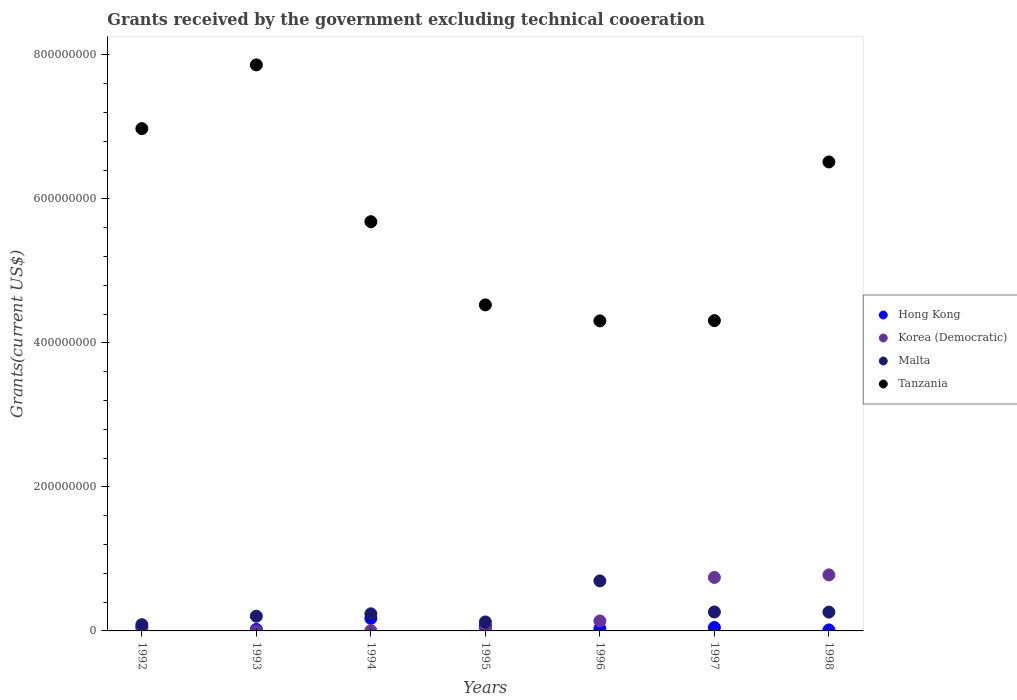Is the number of dotlines equal to the number of legend labels?
Give a very brief answer. Yes. What is the total grants received by the government in Malta in 1998?
Provide a succinct answer. 2.62e+07. Across all years, what is the maximum total grants received by the government in Malta?
Your response must be concise. 6.95e+07. Across all years, what is the minimum total grants received by the government in Malta?
Your answer should be very brief. 8.70e+06. What is the total total grants received by the government in Korea (Democratic) in the graph?
Give a very brief answer. 1.69e+08. What is the difference between the total grants received by the government in Tanzania in 1993 and that in 1995?
Keep it short and to the point. 3.33e+08. What is the difference between the total grants received by the government in Malta in 1998 and the total grants received by the government in Korea (Democratic) in 1994?
Provide a short and direct response. 2.58e+07. What is the average total grants received by the government in Malta per year?
Ensure brevity in your answer.  2.68e+07. In the year 1994, what is the difference between the total grants received by the government in Korea (Democratic) and total grants received by the government in Tanzania?
Provide a succinct answer. -5.68e+08. What is the ratio of the total grants received by the government in Korea (Democratic) in 1992 to that in 1998?
Your answer should be very brief. 0. Is the total grants received by the government in Tanzania in 1992 less than that in 1993?
Your answer should be very brief. Yes. Is the difference between the total grants received by the government in Korea (Democratic) in 1993 and 1997 greater than the difference between the total grants received by the government in Tanzania in 1993 and 1997?
Offer a very short reply. No. What is the difference between the highest and the second highest total grants received by the government in Hong Kong?
Offer a very short reply. 1.10e+07. What is the difference between the highest and the lowest total grants received by the government in Hong Kong?
Keep it short and to the point. 1.60e+07. In how many years, is the total grants received by the government in Malta greater than the average total grants received by the government in Malta taken over all years?
Provide a succinct answer. 1. Is the sum of the total grants received by the government in Hong Kong in 1993 and 1994 greater than the maximum total grants received by the government in Tanzania across all years?
Provide a short and direct response. No. Is it the case that in every year, the sum of the total grants received by the government in Tanzania and total grants received by the government in Hong Kong  is greater than the sum of total grants received by the government in Korea (Democratic) and total grants received by the government in Malta?
Ensure brevity in your answer.  No. Is it the case that in every year, the sum of the total grants received by the government in Malta and total grants received by the government in Tanzania  is greater than the total grants received by the government in Korea (Democratic)?
Your answer should be very brief. Yes. Is the total grants received by the government in Hong Kong strictly greater than the total grants received by the government in Tanzania over the years?
Ensure brevity in your answer.  No. Is the total grants received by the government in Korea (Democratic) strictly less than the total grants received by the government in Hong Kong over the years?
Your answer should be compact. No. How many years are there in the graph?
Your response must be concise. 7. What is the difference between two consecutive major ticks on the Y-axis?
Your answer should be very brief. 2.00e+08. Does the graph contain any zero values?
Keep it short and to the point. No. Does the graph contain grids?
Make the answer very short. No. How many legend labels are there?
Keep it short and to the point. 4. How are the legend labels stacked?
Provide a short and direct response. Vertical. What is the title of the graph?
Your answer should be very brief. Grants received by the government excluding technical cooeration. Does "Small states" appear as one of the legend labels in the graph?
Make the answer very short. No. What is the label or title of the Y-axis?
Your answer should be very brief. Grants(current US$). What is the Grants(current US$) in Hong Kong in 1992?
Your response must be concise. 5.16e+06. What is the Grants(current US$) of Korea (Democratic) in 1992?
Provide a succinct answer. 2.00e+04. What is the Grants(current US$) in Malta in 1992?
Provide a short and direct response. 8.70e+06. What is the Grants(current US$) of Tanzania in 1992?
Your answer should be compact. 6.98e+08. What is the Grants(current US$) in Hong Kong in 1993?
Offer a terse response. 2.14e+06. What is the Grants(current US$) in Korea (Democratic) in 1993?
Offer a very short reply. 4.00e+04. What is the Grants(current US$) of Malta in 1993?
Offer a very short reply. 2.04e+07. What is the Grants(current US$) in Tanzania in 1993?
Provide a succinct answer. 7.86e+08. What is the Grants(current US$) of Hong Kong in 1994?
Provide a short and direct response. 1.74e+07. What is the Grants(current US$) of Korea (Democratic) in 1994?
Ensure brevity in your answer.  3.70e+05. What is the Grants(current US$) of Malta in 1994?
Provide a short and direct response. 2.38e+07. What is the Grants(current US$) in Tanzania in 1994?
Offer a very short reply. 5.68e+08. What is the Grants(current US$) of Hong Kong in 1995?
Keep it short and to the point. 6.44e+06. What is the Grants(current US$) of Korea (Democratic) in 1995?
Give a very brief answer. 2.97e+06. What is the Grants(current US$) of Malta in 1995?
Offer a terse response. 1.25e+07. What is the Grants(current US$) in Tanzania in 1995?
Your response must be concise. 4.53e+08. What is the Grants(current US$) of Hong Kong in 1996?
Your response must be concise. 3.27e+06. What is the Grants(current US$) of Korea (Democratic) in 1996?
Your response must be concise. 1.38e+07. What is the Grants(current US$) of Malta in 1996?
Keep it short and to the point. 6.95e+07. What is the Grants(current US$) in Tanzania in 1996?
Provide a short and direct response. 4.31e+08. What is the Grants(current US$) in Hong Kong in 1997?
Provide a succinct answer. 4.82e+06. What is the Grants(current US$) of Korea (Democratic) in 1997?
Your response must be concise. 7.43e+07. What is the Grants(current US$) in Malta in 1997?
Give a very brief answer. 2.63e+07. What is the Grants(current US$) of Tanzania in 1997?
Provide a short and direct response. 4.31e+08. What is the Grants(current US$) of Hong Kong in 1998?
Your answer should be very brief. 1.39e+06. What is the Grants(current US$) of Korea (Democratic) in 1998?
Make the answer very short. 7.79e+07. What is the Grants(current US$) in Malta in 1998?
Your answer should be compact. 2.62e+07. What is the Grants(current US$) of Tanzania in 1998?
Your answer should be very brief. 6.51e+08. Across all years, what is the maximum Grants(current US$) of Hong Kong?
Keep it short and to the point. 1.74e+07. Across all years, what is the maximum Grants(current US$) of Korea (Democratic)?
Make the answer very short. 7.79e+07. Across all years, what is the maximum Grants(current US$) of Malta?
Provide a succinct answer. 6.95e+07. Across all years, what is the maximum Grants(current US$) of Tanzania?
Provide a short and direct response. 7.86e+08. Across all years, what is the minimum Grants(current US$) in Hong Kong?
Ensure brevity in your answer.  1.39e+06. Across all years, what is the minimum Grants(current US$) of Korea (Democratic)?
Your answer should be very brief. 2.00e+04. Across all years, what is the minimum Grants(current US$) of Malta?
Your answer should be compact. 8.70e+06. Across all years, what is the minimum Grants(current US$) in Tanzania?
Your response must be concise. 4.31e+08. What is the total Grants(current US$) of Hong Kong in the graph?
Provide a succinct answer. 4.06e+07. What is the total Grants(current US$) of Korea (Democratic) in the graph?
Provide a succinct answer. 1.69e+08. What is the total Grants(current US$) in Malta in the graph?
Provide a short and direct response. 1.87e+08. What is the total Grants(current US$) of Tanzania in the graph?
Ensure brevity in your answer.  4.02e+09. What is the difference between the Grants(current US$) of Hong Kong in 1992 and that in 1993?
Your answer should be very brief. 3.02e+06. What is the difference between the Grants(current US$) in Korea (Democratic) in 1992 and that in 1993?
Keep it short and to the point. -2.00e+04. What is the difference between the Grants(current US$) in Malta in 1992 and that in 1993?
Make the answer very short. -1.17e+07. What is the difference between the Grants(current US$) in Tanzania in 1992 and that in 1993?
Your answer should be very brief. -8.86e+07. What is the difference between the Grants(current US$) of Hong Kong in 1992 and that in 1994?
Give a very brief answer. -1.23e+07. What is the difference between the Grants(current US$) of Korea (Democratic) in 1992 and that in 1994?
Offer a terse response. -3.50e+05. What is the difference between the Grants(current US$) of Malta in 1992 and that in 1994?
Provide a succinct answer. -1.51e+07. What is the difference between the Grants(current US$) of Tanzania in 1992 and that in 1994?
Keep it short and to the point. 1.29e+08. What is the difference between the Grants(current US$) of Hong Kong in 1992 and that in 1995?
Provide a short and direct response. -1.28e+06. What is the difference between the Grants(current US$) in Korea (Democratic) in 1992 and that in 1995?
Offer a terse response. -2.95e+06. What is the difference between the Grants(current US$) in Malta in 1992 and that in 1995?
Ensure brevity in your answer.  -3.77e+06. What is the difference between the Grants(current US$) in Tanzania in 1992 and that in 1995?
Ensure brevity in your answer.  2.45e+08. What is the difference between the Grants(current US$) of Hong Kong in 1992 and that in 1996?
Make the answer very short. 1.89e+06. What is the difference between the Grants(current US$) of Korea (Democratic) in 1992 and that in 1996?
Your answer should be compact. -1.38e+07. What is the difference between the Grants(current US$) in Malta in 1992 and that in 1996?
Give a very brief answer. -6.08e+07. What is the difference between the Grants(current US$) of Tanzania in 1992 and that in 1996?
Your response must be concise. 2.67e+08. What is the difference between the Grants(current US$) in Hong Kong in 1992 and that in 1997?
Your response must be concise. 3.40e+05. What is the difference between the Grants(current US$) of Korea (Democratic) in 1992 and that in 1997?
Your response must be concise. -7.42e+07. What is the difference between the Grants(current US$) in Malta in 1992 and that in 1997?
Your answer should be very brief. -1.76e+07. What is the difference between the Grants(current US$) of Tanzania in 1992 and that in 1997?
Provide a succinct answer. 2.67e+08. What is the difference between the Grants(current US$) in Hong Kong in 1992 and that in 1998?
Give a very brief answer. 3.77e+06. What is the difference between the Grants(current US$) of Korea (Democratic) in 1992 and that in 1998?
Offer a terse response. -7.78e+07. What is the difference between the Grants(current US$) of Malta in 1992 and that in 1998?
Your answer should be compact. -1.74e+07. What is the difference between the Grants(current US$) in Tanzania in 1992 and that in 1998?
Provide a succinct answer. 4.63e+07. What is the difference between the Grants(current US$) of Hong Kong in 1993 and that in 1994?
Ensure brevity in your answer.  -1.53e+07. What is the difference between the Grants(current US$) in Korea (Democratic) in 1993 and that in 1994?
Make the answer very short. -3.30e+05. What is the difference between the Grants(current US$) in Malta in 1993 and that in 1994?
Give a very brief answer. -3.34e+06. What is the difference between the Grants(current US$) of Tanzania in 1993 and that in 1994?
Offer a terse response. 2.18e+08. What is the difference between the Grants(current US$) of Hong Kong in 1993 and that in 1995?
Provide a succinct answer. -4.30e+06. What is the difference between the Grants(current US$) of Korea (Democratic) in 1993 and that in 1995?
Provide a succinct answer. -2.93e+06. What is the difference between the Grants(current US$) of Malta in 1993 and that in 1995?
Ensure brevity in your answer.  7.97e+06. What is the difference between the Grants(current US$) of Tanzania in 1993 and that in 1995?
Offer a very short reply. 3.33e+08. What is the difference between the Grants(current US$) of Hong Kong in 1993 and that in 1996?
Give a very brief answer. -1.13e+06. What is the difference between the Grants(current US$) of Korea (Democratic) in 1993 and that in 1996?
Offer a terse response. -1.38e+07. What is the difference between the Grants(current US$) in Malta in 1993 and that in 1996?
Ensure brevity in your answer.  -4.90e+07. What is the difference between the Grants(current US$) in Tanzania in 1993 and that in 1996?
Provide a succinct answer. 3.56e+08. What is the difference between the Grants(current US$) in Hong Kong in 1993 and that in 1997?
Keep it short and to the point. -2.68e+06. What is the difference between the Grants(current US$) in Korea (Democratic) in 1993 and that in 1997?
Your answer should be compact. -7.42e+07. What is the difference between the Grants(current US$) of Malta in 1993 and that in 1997?
Ensure brevity in your answer.  -5.89e+06. What is the difference between the Grants(current US$) in Tanzania in 1993 and that in 1997?
Make the answer very short. 3.55e+08. What is the difference between the Grants(current US$) of Hong Kong in 1993 and that in 1998?
Your answer should be very brief. 7.50e+05. What is the difference between the Grants(current US$) in Korea (Democratic) in 1993 and that in 1998?
Give a very brief answer. -7.78e+07. What is the difference between the Grants(current US$) in Malta in 1993 and that in 1998?
Offer a very short reply. -5.71e+06. What is the difference between the Grants(current US$) of Tanzania in 1993 and that in 1998?
Offer a very short reply. 1.35e+08. What is the difference between the Grants(current US$) of Hong Kong in 1994 and that in 1995?
Provide a succinct answer. 1.10e+07. What is the difference between the Grants(current US$) of Korea (Democratic) in 1994 and that in 1995?
Provide a succinct answer. -2.60e+06. What is the difference between the Grants(current US$) in Malta in 1994 and that in 1995?
Ensure brevity in your answer.  1.13e+07. What is the difference between the Grants(current US$) of Tanzania in 1994 and that in 1995?
Offer a very short reply. 1.16e+08. What is the difference between the Grants(current US$) of Hong Kong in 1994 and that in 1996?
Provide a short and direct response. 1.42e+07. What is the difference between the Grants(current US$) of Korea (Democratic) in 1994 and that in 1996?
Ensure brevity in your answer.  -1.34e+07. What is the difference between the Grants(current US$) in Malta in 1994 and that in 1996?
Your answer should be very brief. -4.57e+07. What is the difference between the Grants(current US$) of Tanzania in 1994 and that in 1996?
Your answer should be very brief. 1.38e+08. What is the difference between the Grants(current US$) in Hong Kong in 1994 and that in 1997?
Make the answer very short. 1.26e+07. What is the difference between the Grants(current US$) of Korea (Democratic) in 1994 and that in 1997?
Provide a succinct answer. -7.39e+07. What is the difference between the Grants(current US$) of Malta in 1994 and that in 1997?
Your answer should be very brief. -2.55e+06. What is the difference between the Grants(current US$) of Tanzania in 1994 and that in 1997?
Your response must be concise. 1.37e+08. What is the difference between the Grants(current US$) in Hong Kong in 1994 and that in 1998?
Provide a short and direct response. 1.60e+07. What is the difference between the Grants(current US$) of Korea (Democratic) in 1994 and that in 1998?
Keep it short and to the point. -7.75e+07. What is the difference between the Grants(current US$) of Malta in 1994 and that in 1998?
Ensure brevity in your answer.  -2.37e+06. What is the difference between the Grants(current US$) in Tanzania in 1994 and that in 1998?
Your answer should be compact. -8.30e+07. What is the difference between the Grants(current US$) of Hong Kong in 1995 and that in 1996?
Your response must be concise. 3.17e+06. What is the difference between the Grants(current US$) of Korea (Democratic) in 1995 and that in 1996?
Ensure brevity in your answer.  -1.08e+07. What is the difference between the Grants(current US$) of Malta in 1995 and that in 1996?
Ensure brevity in your answer.  -5.70e+07. What is the difference between the Grants(current US$) in Tanzania in 1995 and that in 1996?
Offer a very short reply. 2.22e+07. What is the difference between the Grants(current US$) of Hong Kong in 1995 and that in 1997?
Offer a very short reply. 1.62e+06. What is the difference between the Grants(current US$) in Korea (Democratic) in 1995 and that in 1997?
Ensure brevity in your answer.  -7.13e+07. What is the difference between the Grants(current US$) in Malta in 1995 and that in 1997?
Your response must be concise. -1.39e+07. What is the difference between the Grants(current US$) of Tanzania in 1995 and that in 1997?
Provide a short and direct response. 2.18e+07. What is the difference between the Grants(current US$) of Hong Kong in 1995 and that in 1998?
Your answer should be very brief. 5.05e+06. What is the difference between the Grants(current US$) of Korea (Democratic) in 1995 and that in 1998?
Offer a very short reply. -7.49e+07. What is the difference between the Grants(current US$) in Malta in 1995 and that in 1998?
Your response must be concise. -1.37e+07. What is the difference between the Grants(current US$) of Tanzania in 1995 and that in 1998?
Your answer should be compact. -1.99e+08. What is the difference between the Grants(current US$) in Hong Kong in 1996 and that in 1997?
Keep it short and to the point. -1.55e+06. What is the difference between the Grants(current US$) of Korea (Democratic) in 1996 and that in 1997?
Provide a short and direct response. -6.05e+07. What is the difference between the Grants(current US$) in Malta in 1996 and that in 1997?
Provide a succinct answer. 4.32e+07. What is the difference between the Grants(current US$) in Tanzania in 1996 and that in 1997?
Give a very brief answer. -3.80e+05. What is the difference between the Grants(current US$) in Hong Kong in 1996 and that in 1998?
Keep it short and to the point. 1.88e+06. What is the difference between the Grants(current US$) of Korea (Democratic) in 1996 and that in 1998?
Offer a very short reply. -6.41e+07. What is the difference between the Grants(current US$) of Malta in 1996 and that in 1998?
Provide a succinct answer. 4.33e+07. What is the difference between the Grants(current US$) in Tanzania in 1996 and that in 1998?
Your response must be concise. -2.21e+08. What is the difference between the Grants(current US$) in Hong Kong in 1997 and that in 1998?
Make the answer very short. 3.43e+06. What is the difference between the Grants(current US$) of Korea (Democratic) in 1997 and that in 1998?
Your answer should be very brief. -3.60e+06. What is the difference between the Grants(current US$) in Tanzania in 1997 and that in 1998?
Your answer should be very brief. -2.20e+08. What is the difference between the Grants(current US$) of Hong Kong in 1992 and the Grants(current US$) of Korea (Democratic) in 1993?
Your response must be concise. 5.12e+06. What is the difference between the Grants(current US$) of Hong Kong in 1992 and the Grants(current US$) of Malta in 1993?
Your response must be concise. -1.53e+07. What is the difference between the Grants(current US$) of Hong Kong in 1992 and the Grants(current US$) of Tanzania in 1993?
Your answer should be compact. -7.81e+08. What is the difference between the Grants(current US$) of Korea (Democratic) in 1992 and the Grants(current US$) of Malta in 1993?
Your answer should be very brief. -2.04e+07. What is the difference between the Grants(current US$) of Korea (Democratic) in 1992 and the Grants(current US$) of Tanzania in 1993?
Give a very brief answer. -7.86e+08. What is the difference between the Grants(current US$) in Malta in 1992 and the Grants(current US$) in Tanzania in 1993?
Keep it short and to the point. -7.78e+08. What is the difference between the Grants(current US$) of Hong Kong in 1992 and the Grants(current US$) of Korea (Democratic) in 1994?
Make the answer very short. 4.79e+06. What is the difference between the Grants(current US$) in Hong Kong in 1992 and the Grants(current US$) in Malta in 1994?
Your response must be concise. -1.86e+07. What is the difference between the Grants(current US$) in Hong Kong in 1992 and the Grants(current US$) in Tanzania in 1994?
Keep it short and to the point. -5.63e+08. What is the difference between the Grants(current US$) of Korea (Democratic) in 1992 and the Grants(current US$) of Malta in 1994?
Keep it short and to the point. -2.38e+07. What is the difference between the Grants(current US$) of Korea (Democratic) in 1992 and the Grants(current US$) of Tanzania in 1994?
Keep it short and to the point. -5.68e+08. What is the difference between the Grants(current US$) in Malta in 1992 and the Grants(current US$) in Tanzania in 1994?
Offer a terse response. -5.60e+08. What is the difference between the Grants(current US$) in Hong Kong in 1992 and the Grants(current US$) in Korea (Democratic) in 1995?
Your answer should be compact. 2.19e+06. What is the difference between the Grants(current US$) in Hong Kong in 1992 and the Grants(current US$) in Malta in 1995?
Your answer should be very brief. -7.31e+06. What is the difference between the Grants(current US$) of Hong Kong in 1992 and the Grants(current US$) of Tanzania in 1995?
Offer a very short reply. -4.48e+08. What is the difference between the Grants(current US$) of Korea (Democratic) in 1992 and the Grants(current US$) of Malta in 1995?
Offer a terse response. -1.24e+07. What is the difference between the Grants(current US$) of Korea (Democratic) in 1992 and the Grants(current US$) of Tanzania in 1995?
Your answer should be compact. -4.53e+08. What is the difference between the Grants(current US$) of Malta in 1992 and the Grants(current US$) of Tanzania in 1995?
Keep it short and to the point. -4.44e+08. What is the difference between the Grants(current US$) of Hong Kong in 1992 and the Grants(current US$) of Korea (Democratic) in 1996?
Your answer should be very brief. -8.65e+06. What is the difference between the Grants(current US$) in Hong Kong in 1992 and the Grants(current US$) in Malta in 1996?
Provide a succinct answer. -6.43e+07. What is the difference between the Grants(current US$) of Hong Kong in 1992 and the Grants(current US$) of Tanzania in 1996?
Offer a very short reply. -4.25e+08. What is the difference between the Grants(current US$) in Korea (Democratic) in 1992 and the Grants(current US$) in Malta in 1996?
Offer a very short reply. -6.95e+07. What is the difference between the Grants(current US$) of Korea (Democratic) in 1992 and the Grants(current US$) of Tanzania in 1996?
Ensure brevity in your answer.  -4.31e+08. What is the difference between the Grants(current US$) in Malta in 1992 and the Grants(current US$) in Tanzania in 1996?
Give a very brief answer. -4.22e+08. What is the difference between the Grants(current US$) of Hong Kong in 1992 and the Grants(current US$) of Korea (Democratic) in 1997?
Ensure brevity in your answer.  -6.91e+07. What is the difference between the Grants(current US$) in Hong Kong in 1992 and the Grants(current US$) in Malta in 1997?
Offer a terse response. -2.12e+07. What is the difference between the Grants(current US$) of Hong Kong in 1992 and the Grants(current US$) of Tanzania in 1997?
Ensure brevity in your answer.  -4.26e+08. What is the difference between the Grants(current US$) of Korea (Democratic) in 1992 and the Grants(current US$) of Malta in 1997?
Make the answer very short. -2.63e+07. What is the difference between the Grants(current US$) in Korea (Democratic) in 1992 and the Grants(current US$) in Tanzania in 1997?
Keep it short and to the point. -4.31e+08. What is the difference between the Grants(current US$) in Malta in 1992 and the Grants(current US$) in Tanzania in 1997?
Your answer should be very brief. -4.22e+08. What is the difference between the Grants(current US$) in Hong Kong in 1992 and the Grants(current US$) in Korea (Democratic) in 1998?
Ensure brevity in your answer.  -7.27e+07. What is the difference between the Grants(current US$) in Hong Kong in 1992 and the Grants(current US$) in Malta in 1998?
Provide a succinct answer. -2.10e+07. What is the difference between the Grants(current US$) of Hong Kong in 1992 and the Grants(current US$) of Tanzania in 1998?
Your answer should be very brief. -6.46e+08. What is the difference between the Grants(current US$) in Korea (Democratic) in 1992 and the Grants(current US$) in Malta in 1998?
Provide a succinct answer. -2.61e+07. What is the difference between the Grants(current US$) of Korea (Democratic) in 1992 and the Grants(current US$) of Tanzania in 1998?
Provide a short and direct response. -6.51e+08. What is the difference between the Grants(current US$) in Malta in 1992 and the Grants(current US$) in Tanzania in 1998?
Your answer should be compact. -6.43e+08. What is the difference between the Grants(current US$) of Hong Kong in 1993 and the Grants(current US$) of Korea (Democratic) in 1994?
Keep it short and to the point. 1.77e+06. What is the difference between the Grants(current US$) in Hong Kong in 1993 and the Grants(current US$) in Malta in 1994?
Make the answer very short. -2.16e+07. What is the difference between the Grants(current US$) of Hong Kong in 1993 and the Grants(current US$) of Tanzania in 1994?
Give a very brief answer. -5.66e+08. What is the difference between the Grants(current US$) in Korea (Democratic) in 1993 and the Grants(current US$) in Malta in 1994?
Keep it short and to the point. -2.37e+07. What is the difference between the Grants(current US$) of Korea (Democratic) in 1993 and the Grants(current US$) of Tanzania in 1994?
Keep it short and to the point. -5.68e+08. What is the difference between the Grants(current US$) of Malta in 1993 and the Grants(current US$) of Tanzania in 1994?
Ensure brevity in your answer.  -5.48e+08. What is the difference between the Grants(current US$) in Hong Kong in 1993 and the Grants(current US$) in Korea (Democratic) in 1995?
Your answer should be compact. -8.30e+05. What is the difference between the Grants(current US$) in Hong Kong in 1993 and the Grants(current US$) in Malta in 1995?
Give a very brief answer. -1.03e+07. What is the difference between the Grants(current US$) of Hong Kong in 1993 and the Grants(current US$) of Tanzania in 1995?
Provide a short and direct response. -4.51e+08. What is the difference between the Grants(current US$) of Korea (Democratic) in 1993 and the Grants(current US$) of Malta in 1995?
Your answer should be compact. -1.24e+07. What is the difference between the Grants(current US$) in Korea (Democratic) in 1993 and the Grants(current US$) in Tanzania in 1995?
Provide a short and direct response. -4.53e+08. What is the difference between the Grants(current US$) of Malta in 1993 and the Grants(current US$) of Tanzania in 1995?
Your answer should be very brief. -4.32e+08. What is the difference between the Grants(current US$) in Hong Kong in 1993 and the Grants(current US$) in Korea (Democratic) in 1996?
Your answer should be compact. -1.17e+07. What is the difference between the Grants(current US$) in Hong Kong in 1993 and the Grants(current US$) in Malta in 1996?
Ensure brevity in your answer.  -6.73e+07. What is the difference between the Grants(current US$) in Hong Kong in 1993 and the Grants(current US$) in Tanzania in 1996?
Ensure brevity in your answer.  -4.28e+08. What is the difference between the Grants(current US$) in Korea (Democratic) in 1993 and the Grants(current US$) in Malta in 1996?
Make the answer very short. -6.94e+07. What is the difference between the Grants(current US$) of Korea (Democratic) in 1993 and the Grants(current US$) of Tanzania in 1996?
Make the answer very short. -4.31e+08. What is the difference between the Grants(current US$) in Malta in 1993 and the Grants(current US$) in Tanzania in 1996?
Your answer should be very brief. -4.10e+08. What is the difference between the Grants(current US$) of Hong Kong in 1993 and the Grants(current US$) of Korea (Democratic) in 1997?
Give a very brief answer. -7.21e+07. What is the difference between the Grants(current US$) of Hong Kong in 1993 and the Grants(current US$) of Malta in 1997?
Make the answer very short. -2.42e+07. What is the difference between the Grants(current US$) of Hong Kong in 1993 and the Grants(current US$) of Tanzania in 1997?
Make the answer very short. -4.29e+08. What is the difference between the Grants(current US$) in Korea (Democratic) in 1993 and the Grants(current US$) in Malta in 1997?
Provide a succinct answer. -2.63e+07. What is the difference between the Grants(current US$) in Korea (Democratic) in 1993 and the Grants(current US$) in Tanzania in 1997?
Offer a terse response. -4.31e+08. What is the difference between the Grants(current US$) of Malta in 1993 and the Grants(current US$) of Tanzania in 1997?
Your response must be concise. -4.11e+08. What is the difference between the Grants(current US$) in Hong Kong in 1993 and the Grants(current US$) in Korea (Democratic) in 1998?
Your answer should be compact. -7.57e+07. What is the difference between the Grants(current US$) in Hong Kong in 1993 and the Grants(current US$) in Malta in 1998?
Your answer should be very brief. -2.40e+07. What is the difference between the Grants(current US$) of Hong Kong in 1993 and the Grants(current US$) of Tanzania in 1998?
Provide a succinct answer. -6.49e+08. What is the difference between the Grants(current US$) of Korea (Democratic) in 1993 and the Grants(current US$) of Malta in 1998?
Your answer should be compact. -2.61e+07. What is the difference between the Grants(current US$) of Korea (Democratic) in 1993 and the Grants(current US$) of Tanzania in 1998?
Make the answer very short. -6.51e+08. What is the difference between the Grants(current US$) in Malta in 1993 and the Grants(current US$) in Tanzania in 1998?
Your response must be concise. -6.31e+08. What is the difference between the Grants(current US$) of Hong Kong in 1994 and the Grants(current US$) of Korea (Democratic) in 1995?
Give a very brief answer. 1.44e+07. What is the difference between the Grants(current US$) of Hong Kong in 1994 and the Grants(current US$) of Malta in 1995?
Offer a very short reply. 4.95e+06. What is the difference between the Grants(current US$) of Hong Kong in 1994 and the Grants(current US$) of Tanzania in 1995?
Ensure brevity in your answer.  -4.35e+08. What is the difference between the Grants(current US$) in Korea (Democratic) in 1994 and the Grants(current US$) in Malta in 1995?
Your answer should be very brief. -1.21e+07. What is the difference between the Grants(current US$) of Korea (Democratic) in 1994 and the Grants(current US$) of Tanzania in 1995?
Give a very brief answer. -4.52e+08. What is the difference between the Grants(current US$) of Malta in 1994 and the Grants(current US$) of Tanzania in 1995?
Your answer should be compact. -4.29e+08. What is the difference between the Grants(current US$) of Hong Kong in 1994 and the Grants(current US$) of Korea (Democratic) in 1996?
Keep it short and to the point. 3.61e+06. What is the difference between the Grants(current US$) of Hong Kong in 1994 and the Grants(current US$) of Malta in 1996?
Offer a terse response. -5.21e+07. What is the difference between the Grants(current US$) in Hong Kong in 1994 and the Grants(current US$) in Tanzania in 1996?
Your answer should be compact. -4.13e+08. What is the difference between the Grants(current US$) of Korea (Democratic) in 1994 and the Grants(current US$) of Malta in 1996?
Ensure brevity in your answer.  -6.91e+07. What is the difference between the Grants(current US$) in Korea (Democratic) in 1994 and the Grants(current US$) in Tanzania in 1996?
Ensure brevity in your answer.  -4.30e+08. What is the difference between the Grants(current US$) of Malta in 1994 and the Grants(current US$) of Tanzania in 1996?
Make the answer very short. -4.07e+08. What is the difference between the Grants(current US$) of Hong Kong in 1994 and the Grants(current US$) of Korea (Democratic) in 1997?
Offer a very short reply. -5.68e+07. What is the difference between the Grants(current US$) of Hong Kong in 1994 and the Grants(current US$) of Malta in 1997?
Ensure brevity in your answer.  -8.91e+06. What is the difference between the Grants(current US$) in Hong Kong in 1994 and the Grants(current US$) in Tanzania in 1997?
Offer a terse response. -4.14e+08. What is the difference between the Grants(current US$) of Korea (Democratic) in 1994 and the Grants(current US$) of Malta in 1997?
Offer a terse response. -2.60e+07. What is the difference between the Grants(current US$) of Korea (Democratic) in 1994 and the Grants(current US$) of Tanzania in 1997?
Provide a short and direct response. -4.31e+08. What is the difference between the Grants(current US$) in Malta in 1994 and the Grants(current US$) in Tanzania in 1997?
Your answer should be compact. -4.07e+08. What is the difference between the Grants(current US$) in Hong Kong in 1994 and the Grants(current US$) in Korea (Democratic) in 1998?
Keep it short and to the point. -6.04e+07. What is the difference between the Grants(current US$) of Hong Kong in 1994 and the Grants(current US$) of Malta in 1998?
Provide a succinct answer. -8.73e+06. What is the difference between the Grants(current US$) of Hong Kong in 1994 and the Grants(current US$) of Tanzania in 1998?
Your answer should be compact. -6.34e+08. What is the difference between the Grants(current US$) in Korea (Democratic) in 1994 and the Grants(current US$) in Malta in 1998?
Your answer should be compact. -2.58e+07. What is the difference between the Grants(current US$) of Korea (Democratic) in 1994 and the Grants(current US$) of Tanzania in 1998?
Give a very brief answer. -6.51e+08. What is the difference between the Grants(current US$) in Malta in 1994 and the Grants(current US$) in Tanzania in 1998?
Keep it short and to the point. -6.28e+08. What is the difference between the Grants(current US$) in Hong Kong in 1995 and the Grants(current US$) in Korea (Democratic) in 1996?
Make the answer very short. -7.37e+06. What is the difference between the Grants(current US$) of Hong Kong in 1995 and the Grants(current US$) of Malta in 1996?
Your response must be concise. -6.30e+07. What is the difference between the Grants(current US$) in Hong Kong in 1995 and the Grants(current US$) in Tanzania in 1996?
Keep it short and to the point. -4.24e+08. What is the difference between the Grants(current US$) in Korea (Democratic) in 1995 and the Grants(current US$) in Malta in 1996?
Your answer should be very brief. -6.65e+07. What is the difference between the Grants(current US$) of Korea (Democratic) in 1995 and the Grants(current US$) of Tanzania in 1996?
Make the answer very short. -4.28e+08. What is the difference between the Grants(current US$) of Malta in 1995 and the Grants(current US$) of Tanzania in 1996?
Offer a very short reply. -4.18e+08. What is the difference between the Grants(current US$) of Hong Kong in 1995 and the Grants(current US$) of Korea (Democratic) in 1997?
Ensure brevity in your answer.  -6.78e+07. What is the difference between the Grants(current US$) in Hong Kong in 1995 and the Grants(current US$) in Malta in 1997?
Offer a terse response. -1.99e+07. What is the difference between the Grants(current US$) in Hong Kong in 1995 and the Grants(current US$) in Tanzania in 1997?
Offer a very short reply. -4.25e+08. What is the difference between the Grants(current US$) of Korea (Democratic) in 1995 and the Grants(current US$) of Malta in 1997?
Give a very brief answer. -2.34e+07. What is the difference between the Grants(current US$) in Korea (Democratic) in 1995 and the Grants(current US$) in Tanzania in 1997?
Make the answer very short. -4.28e+08. What is the difference between the Grants(current US$) in Malta in 1995 and the Grants(current US$) in Tanzania in 1997?
Your answer should be very brief. -4.19e+08. What is the difference between the Grants(current US$) in Hong Kong in 1995 and the Grants(current US$) in Korea (Democratic) in 1998?
Give a very brief answer. -7.14e+07. What is the difference between the Grants(current US$) of Hong Kong in 1995 and the Grants(current US$) of Malta in 1998?
Ensure brevity in your answer.  -1.97e+07. What is the difference between the Grants(current US$) in Hong Kong in 1995 and the Grants(current US$) in Tanzania in 1998?
Your answer should be very brief. -6.45e+08. What is the difference between the Grants(current US$) in Korea (Democratic) in 1995 and the Grants(current US$) in Malta in 1998?
Offer a terse response. -2.32e+07. What is the difference between the Grants(current US$) of Korea (Democratic) in 1995 and the Grants(current US$) of Tanzania in 1998?
Offer a terse response. -6.48e+08. What is the difference between the Grants(current US$) in Malta in 1995 and the Grants(current US$) in Tanzania in 1998?
Provide a short and direct response. -6.39e+08. What is the difference between the Grants(current US$) of Hong Kong in 1996 and the Grants(current US$) of Korea (Democratic) in 1997?
Give a very brief answer. -7.10e+07. What is the difference between the Grants(current US$) in Hong Kong in 1996 and the Grants(current US$) in Malta in 1997?
Offer a very short reply. -2.31e+07. What is the difference between the Grants(current US$) of Hong Kong in 1996 and the Grants(current US$) of Tanzania in 1997?
Give a very brief answer. -4.28e+08. What is the difference between the Grants(current US$) of Korea (Democratic) in 1996 and the Grants(current US$) of Malta in 1997?
Provide a succinct answer. -1.25e+07. What is the difference between the Grants(current US$) of Korea (Democratic) in 1996 and the Grants(current US$) of Tanzania in 1997?
Ensure brevity in your answer.  -4.17e+08. What is the difference between the Grants(current US$) of Malta in 1996 and the Grants(current US$) of Tanzania in 1997?
Your answer should be compact. -3.62e+08. What is the difference between the Grants(current US$) of Hong Kong in 1996 and the Grants(current US$) of Korea (Democratic) in 1998?
Keep it short and to the point. -7.46e+07. What is the difference between the Grants(current US$) of Hong Kong in 1996 and the Grants(current US$) of Malta in 1998?
Offer a very short reply. -2.29e+07. What is the difference between the Grants(current US$) of Hong Kong in 1996 and the Grants(current US$) of Tanzania in 1998?
Give a very brief answer. -6.48e+08. What is the difference between the Grants(current US$) of Korea (Democratic) in 1996 and the Grants(current US$) of Malta in 1998?
Your response must be concise. -1.23e+07. What is the difference between the Grants(current US$) of Korea (Democratic) in 1996 and the Grants(current US$) of Tanzania in 1998?
Offer a very short reply. -6.38e+08. What is the difference between the Grants(current US$) in Malta in 1996 and the Grants(current US$) in Tanzania in 1998?
Your answer should be very brief. -5.82e+08. What is the difference between the Grants(current US$) of Hong Kong in 1997 and the Grants(current US$) of Korea (Democratic) in 1998?
Offer a terse response. -7.30e+07. What is the difference between the Grants(current US$) of Hong Kong in 1997 and the Grants(current US$) of Malta in 1998?
Offer a terse response. -2.13e+07. What is the difference between the Grants(current US$) in Hong Kong in 1997 and the Grants(current US$) in Tanzania in 1998?
Offer a very short reply. -6.47e+08. What is the difference between the Grants(current US$) in Korea (Democratic) in 1997 and the Grants(current US$) in Malta in 1998?
Provide a succinct answer. 4.81e+07. What is the difference between the Grants(current US$) of Korea (Democratic) in 1997 and the Grants(current US$) of Tanzania in 1998?
Ensure brevity in your answer.  -5.77e+08. What is the difference between the Grants(current US$) of Malta in 1997 and the Grants(current US$) of Tanzania in 1998?
Your response must be concise. -6.25e+08. What is the average Grants(current US$) in Hong Kong per year?
Ensure brevity in your answer.  5.81e+06. What is the average Grants(current US$) in Korea (Democratic) per year?
Offer a very short reply. 2.42e+07. What is the average Grants(current US$) in Malta per year?
Keep it short and to the point. 2.68e+07. What is the average Grants(current US$) of Tanzania per year?
Offer a terse response. 5.74e+08. In the year 1992, what is the difference between the Grants(current US$) of Hong Kong and Grants(current US$) of Korea (Democratic)?
Your response must be concise. 5.14e+06. In the year 1992, what is the difference between the Grants(current US$) in Hong Kong and Grants(current US$) in Malta?
Your answer should be compact. -3.54e+06. In the year 1992, what is the difference between the Grants(current US$) in Hong Kong and Grants(current US$) in Tanzania?
Ensure brevity in your answer.  -6.93e+08. In the year 1992, what is the difference between the Grants(current US$) in Korea (Democratic) and Grants(current US$) in Malta?
Your answer should be compact. -8.68e+06. In the year 1992, what is the difference between the Grants(current US$) of Korea (Democratic) and Grants(current US$) of Tanzania?
Your response must be concise. -6.98e+08. In the year 1992, what is the difference between the Grants(current US$) of Malta and Grants(current US$) of Tanzania?
Offer a very short reply. -6.89e+08. In the year 1993, what is the difference between the Grants(current US$) of Hong Kong and Grants(current US$) of Korea (Democratic)?
Your answer should be compact. 2.10e+06. In the year 1993, what is the difference between the Grants(current US$) of Hong Kong and Grants(current US$) of Malta?
Provide a succinct answer. -1.83e+07. In the year 1993, what is the difference between the Grants(current US$) of Hong Kong and Grants(current US$) of Tanzania?
Offer a very short reply. -7.84e+08. In the year 1993, what is the difference between the Grants(current US$) in Korea (Democratic) and Grants(current US$) in Malta?
Provide a succinct answer. -2.04e+07. In the year 1993, what is the difference between the Grants(current US$) of Korea (Democratic) and Grants(current US$) of Tanzania?
Your response must be concise. -7.86e+08. In the year 1993, what is the difference between the Grants(current US$) in Malta and Grants(current US$) in Tanzania?
Offer a very short reply. -7.66e+08. In the year 1994, what is the difference between the Grants(current US$) in Hong Kong and Grants(current US$) in Korea (Democratic)?
Provide a succinct answer. 1.70e+07. In the year 1994, what is the difference between the Grants(current US$) of Hong Kong and Grants(current US$) of Malta?
Give a very brief answer. -6.36e+06. In the year 1994, what is the difference between the Grants(current US$) of Hong Kong and Grants(current US$) of Tanzania?
Your answer should be compact. -5.51e+08. In the year 1994, what is the difference between the Grants(current US$) in Korea (Democratic) and Grants(current US$) in Malta?
Keep it short and to the point. -2.34e+07. In the year 1994, what is the difference between the Grants(current US$) in Korea (Democratic) and Grants(current US$) in Tanzania?
Make the answer very short. -5.68e+08. In the year 1994, what is the difference between the Grants(current US$) of Malta and Grants(current US$) of Tanzania?
Offer a very short reply. -5.45e+08. In the year 1995, what is the difference between the Grants(current US$) in Hong Kong and Grants(current US$) in Korea (Democratic)?
Offer a very short reply. 3.47e+06. In the year 1995, what is the difference between the Grants(current US$) of Hong Kong and Grants(current US$) of Malta?
Your response must be concise. -6.03e+06. In the year 1995, what is the difference between the Grants(current US$) in Hong Kong and Grants(current US$) in Tanzania?
Your response must be concise. -4.46e+08. In the year 1995, what is the difference between the Grants(current US$) in Korea (Democratic) and Grants(current US$) in Malta?
Make the answer very short. -9.50e+06. In the year 1995, what is the difference between the Grants(current US$) of Korea (Democratic) and Grants(current US$) of Tanzania?
Make the answer very short. -4.50e+08. In the year 1995, what is the difference between the Grants(current US$) in Malta and Grants(current US$) in Tanzania?
Your response must be concise. -4.40e+08. In the year 1996, what is the difference between the Grants(current US$) in Hong Kong and Grants(current US$) in Korea (Democratic)?
Your answer should be very brief. -1.05e+07. In the year 1996, what is the difference between the Grants(current US$) of Hong Kong and Grants(current US$) of Malta?
Your response must be concise. -6.62e+07. In the year 1996, what is the difference between the Grants(current US$) of Hong Kong and Grants(current US$) of Tanzania?
Provide a short and direct response. -4.27e+08. In the year 1996, what is the difference between the Grants(current US$) of Korea (Democratic) and Grants(current US$) of Malta?
Your response must be concise. -5.57e+07. In the year 1996, what is the difference between the Grants(current US$) of Korea (Democratic) and Grants(current US$) of Tanzania?
Give a very brief answer. -4.17e+08. In the year 1996, what is the difference between the Grants(current US$) of Malta and Grants(current US$) of Tanzania?
Your response must be concise. -3.61e+08. In the year 1997, what is the difference between the Grants(current US$) of Hong Kong and Grants(current US$) of Korea (Democratic)?
Offer a very short reply. -6.94e+07. In the year 1997, what is the difference between the Grants(current US$) of Hong Kong and Grants(current US$) of Malta?
Keep it short and to the point. -2.15e+07. In the year 1997, what is the difference between the Grants(current US$) in Hong Kong and Grants(current US$) in Tanzania?
Offer a terse response. -4.26e+08. In the year 1997, what is the difference between the Grants(current US$) of Korea (Democratic) and Grants(current US$) of Malta?
Your answer should be compact. 4.79e+07. In the year 1997, what is the difference between the Grants(current US$) in Korea (Democratic) and Grants(current US$) in Tanzania?
Your answer should be compact. -3.57e+08. In the year 1997, what is the difference between the Grants(current US$) in Malta and Grants(current US$) in Tanzania?
Give a very brief answer. -4.05e+08. In the year 1998, what is the difference between the Grants(current US$) in Hong Kong and Grants(current US$) in Korea (Democratic)?
Offer a terse response. -7.65e+07. In the year 1998, what is the difference between the Grants(current US$) in Hong Kong and Grants(current US$) in Malta?
Offer a terse response. -2.48e+07. In the year 1998, what is the difference between the Grants(current US$) of Hong Kong and Grants(current US$) of Tanzania?
Your answer should be very brief. -6.50e+08. In the year 1998, what is the difference between the Grants(current US$) in Korea (Democratic) and Grants(current US$) in Malta?
Your answer should be very brief. 5.17e+07. In the year 1998, what is the difference between the Grants(current US$) of Korea (Democratic) and Grants(current US$) of Tanzania?
Your answer should be compact. -5.74e+08. In the year 1998, what is the difference between the Grants(current US$) in Malta and Grants(current US$) in Tanzania?
Ensure brevity in your answer.  -6.25e+08. What is the ratio of the Grants(current US$) of Hong Kong in 1992 to that in 1993?
Give a very brief answer. 2.41. What is the ratio of the Grants(current US$) of Korea (Democratic) in 1992 to that in 1993?
Your answer should be compact. 0.5. What is the ratio of the Grants(current US$) of Malta in 1992 to that in 1993?
Make the answer very short. 0.43. What is the ratio of the Grants(current US$) of Tanzania in 1992 to that in 1993?
Give a very brief answer. 0.89. What is the ratio of the Grants(current US$) of Hong Kong in 1992 to that in 1994?
Your answer should be very brief. 0.3. What is the ratio of the Grants(current US$) of Korea (Democratic) in 1992 to that in 1994?
Offer a terse response. 0.05. What is the ratio of the Grants(current US$) in Malta in 1992 to that in 1994?
Make the answer very short. 0.37. What is the ratio of the Grants(current US$) of Tanzania in 1992 to that in 1994?
Ensure brevity in your answer.  1.23. What is the ratio of the Grants(current US$) in Hong Kong in 1992 to that in 1995?
Offer a very short reply. 0.8. What is the ratio of the Grants(current US$) in Korea (Democratic) in 1992 to that in 1995?
Keep it short and to the point. 0.01. What is the ratio of the Grants(current US$) in Malta in 1992 to that in 1995?
Give a very brief answer. 0.7. What is the ratio of the Grants(current US$) of Tanzania in 1992 to that in 1995?
Your answer should be compact. 1.54. What is the ratio of the Grants(current US$) of Hong Kong in 1992 to that in 1996?
Provide a succinct answer. 1.58. What is the ratio of the Grants(current US$) of Korea (Democratic) in 1992 to that in 1996?
Make the answer very short. 0. What is the ratio of the Grants(current US$) of Malta in 1992 to that in 1996?
Your answer should be compact. 0.13. What is the ratio of the Grants(current US$) of Tanzania in 1992 to that in 1996?
Your answer should be very brief. 1.62. What is the ratio of the Grants(current US$) in Hong Kong in 1992 to that in 1997?
Your answer should be very brief. 1.07. What is the ratio of the Grants(current US$) in Korea (Democratic) in 1992 to that in 1997?
Ensure brevity in your answer.  0. What is the ratio of the Grants(current US$) of Malta in 1992 to that in 1997?
Your answer should be very brief. 0.33. What is the ratio of the Grants(current US$) in Tanzania in 1992 to that in 1997?
Make the answer very short. 1.62. What is the ratio of the Grants(current US$) of Hong Kong in 1992 to that in 1998?
Your answer should be very brief. 3.71. What is the ratio of the Grants(current US$) of Malta in 1992 to that in 1998?
Offer a terse response. 0.33. What is the ratio of the Grants(current US$) in Tanzania in 1992 to that in 1998?
Your response must be concise. 1.07. What is the ratio of the Grants(current US$) of Hong Kong in 1993 to that in 1994?
Make the answer very short. 0.12. What is the ratio of the Grants(current US$) of Korea (Democratic) in 1993 to that in 1994?
Your answer should be compact. 0.11. What is the ratio of the Grants(current US$) of Malta in 1993 to that in 1994?
Offer a very short reply. 0.86. What is the ratio of the Grants(current US$) in Tanzania in 1993 to that in 1994?
Your answer should be compact. 1.38. What is the ratio of the Grants(current US$) of Hong Kong in 1993 to that in 1995?
Provide a short and direct response. 0.33. What is the ratio of the Grants(current US$) of Korea (Democratic) in 1993 to that in 1995?
Offer a terse response. 0.01. What is the ratio of the Grants(current US$) of Malta in 1993 to that in 1995?
Provide a succinct answer. 1.64. What is the ratio of the Grants(current US$) in Tanzania in 1993 to that in 1995?
Ensure brevity in your answer.  1.74. What is the ratio of the Grants(current US$) of Hong Kong in 1993 to that in 1996?
Make the answer very short. 0.65. What is the ratio of the Grants(current US$) in Korea (Democratic) in 1993 to that in 1996?
Your response must be concise. 0. What is the ratio of the Grants(current US$) of Malta in 1993 to that in 1996?
Offer a terse response. 0.29. What is the ratio of the Grants(current US$) of Tanzania in 1993 to that in 1996?
Offer a very short reply. 1.83. What is the ratio of the Grants(current US$) in Hong Kong in 1993 to that in 1997?
Offer a terse response. 0.44. What is the ratio of the Grants(current US$) of Korea (Democratic) in 1993 to that in 1997?
Ensure brevity in your answer.  0. What is the ratio of the Grants(current US$) in Malta in 1993 to that in 1997?
Offer a terse response. 0.78. What is the ratio of the Grants(current US$) of Tanzania in 1993 to that in 1997?
Make the answer very short. 1.82. What is the ratio of the Grants(current US$) in Hong Kong in 1993 to that in 1998?
Give a very brief answer. 1.54. What is the ratio of the Grants(current US$) in Korea (Democratic) in 1993 to that in 1998?
Provide a succinct answer. 0. What is the ratio of the Grants(current US$) in Malta in 1993 to that in 1998?
Your answer should be very brief. 0.78. What is the ratio of the Grants(current US$) in Tanzania in 1993 to that in 1998?
Your answer should be compact. 1.21. What is the ratio of the Grants(current US$) in Hong Kong in 1994 to that in 1995?
Provide a short and direct response. 2.71. What is the ratio of the Grants(current US$) in Korea (Democratic) in 1994 to that in 1995?
Provide a short and direct response. 0.12. What is the ratio of the Grants(current US$) in Malta in 1994 to that in 1995?
Provide a short and direct response. 1.91. What is the ratio of the Grants(current US$) of Tanzania in 1994 to that in 1995?
Offer a terse response. 1.26. What is the ratio of the Grants(current US$) of Hong Kong in 1994 to that in 1996?
Offer a very short reply. 5.33. What is the ratio of the Grants(current US$) of Korea (Democratic) in 1994 to that in 1996?
Your answer should be very brief. 0.03. What is the ratio of the Grants(current US$) of Malta in 1994 to that in 1996?
Your answer should be compact. 0.34. What is the ratio of the Grants(current US$) in Tanzania in 1994 to that in 1996?
Your response must be concise. 1.32. What is the ratio of the Grants(current US$) of Hong Kong in 1994 to that in 1997?
Your answer should be compact. 3.61. What is the ratio of the Grants(current US$) in Korea (Democratic) in 1994 to that in 1997?
Your response must be concise. 0.01. What is the ratio of the Grants(current US$) in Malta in 1994 to that in 1997?
Ensure brevity in your answer.  0.9. What is the ratio of the Grants(current US$) of Tanzania in 1994 to that in 1997?
Your response must be concise. 1.32. What is the ratio of the Grants(current US$) of Hong Kong in 1994 to that in 1998?
Give a very brief answer. 12.53. What is the ratio of the Grants(current US$) of Korea (Democratic) in 1994 to that in 1998?
Make the answer very short. 0. What is the ratio of the Grants(current US$) in Malta in 1994 to that in 1998?
Make the answer very short. 0.91. What is the ratio of the Grants(current US$) in Tanzania in 1994 to that in 1998?
Your answer should be very brief. 0.87. What is the ratio of the Grants(current US$) of Hong Kong in 1995 to that in 1996?
Offer a very short reply. 1.97. What is the ratio of the Grants(current US$) in Korea (Democratic) in 1995 to that in 1996?
Provide a short and direct response. 0.22. What is the ratio of the Grants(current US$) in Malta in 1995 to that in 1996?
Make the answer very short. 0.18. What is the ratio of the Grants(current US$) in Tanzania in 1995 to that in 1996?
Keep it short and to the point. 1.05. What is the ratio of the Grants(current US$) of Hong Kong in 1995 to that in 1997?
Provide a short and direct response. 1.34. What is the ratio of the Grants(current US$) of Korea (Democratic) in 1995 to that in 1997?
Ensure brevity in your answer.  0.04. What is the ratio of the Grants(current US$) in Malta in 1995 to that in 1997?
Keep it short and to the point. 0.47. What is the ratio of the Grants(current US$) of Tanzania in 1995 to that in 1997?
Offer a terse response. 1.05. What is the ratio of the Grants(current US$) of Hong Kong in 1995 to that in 1998?
Ensure brevity in your answer.  4.63. What is the ratio of the Grants(current US$) in Korea (Democratic) in 1995 to that in 1998?
Ensure brevity in your answer.  0.04. What is the ratio of the Grants(current US$) of Malta in 1995 to that in 1998?
Your answer should be compact. 0.48. What is the ratio of the Grants(current US$) in Tanzania in 1995 to that in 1998?
Your answer should be compact. 0.7. What is the ratio of the Grants(current US$) of Hong Kong in 1996 to that in 1997?
Your response must be concise. 0.68. What is the ratio of the Grants(current US$) of Korea (Democratic) in 1996 to that in 1997?
Your response must be concise. 0.19. What is the ratio of the Grants(current US$) in Malta in 1996 to that in 1997?
Ensure brevity in your answer.  2.64. What is the ratio of the Grants(current US$) of Hong Kong in 1996 to that in 1998?
Your answer should be very brief. 2.35. What is the ratio of the Grants(current US$) in Korea (Democratic) in 1996 to that in 1998?
Your answer should be compact. 0.18. What is the ratio of the Grants(current US$) in Malta in 1996 to that in 1998?
Your answer should be very brief. 2.66. What is the ratio of the Grants(current US$) of Tanzania in 1996 to that in 1998?
Give a very brief answer. 0.66. What is the ratio of the Grants(current US$) in Hong Kong in 1997 to that in 1998?
Offer a terse response. 3.47. What is the ratio of the Grants(current US$) of Korea (Democratic) in 1997 to that in 1998?
Make the answer very short. 0.95. What is the ratio of the Grants(current US$) of Malta in 1997 to that in 1998?
Your response must be concise. 1.01. What is the ratio of the Grants(current US$) in Tanzania in 1997 to that in 1998?
Your answer should be very brief. 0.66. What is the difference between the highest and the second highest Grants(current US$) in Hong Kong?
Keep it short and to the point. 1.10e+07. What is the difference between the highest and the second highest Grants(current US$) in Korea (Democratic)?
Keep it short and to the point. 3.60e+06. What is the difference between the highest and the second highest Grants(current US$) of Malta?
Keep it short and to the point. 4.32e+07. What is the difference between the highest and the second highest Grants(current US$) in Tanzania?
Give a very brief answer. 8.86e+07. What is the difference between the highest and the lowest Grants(current US$) in Hong Kong?
Provide a succinct answer. 1.60e+07. What is the difference between the highest and the lowest Grants(current US$) of Korea (Democratic)?
Give a very brief answer. 7.78e+07. What is the difference between the highest and the lowest Grants(current US$) in Malta?
Your answer should be very brief. 6.08e+07. What is the difference between the highest and the lowest Grants(current US$) of Tanzania?
Provide a succinct answer. 3.56e+08. 